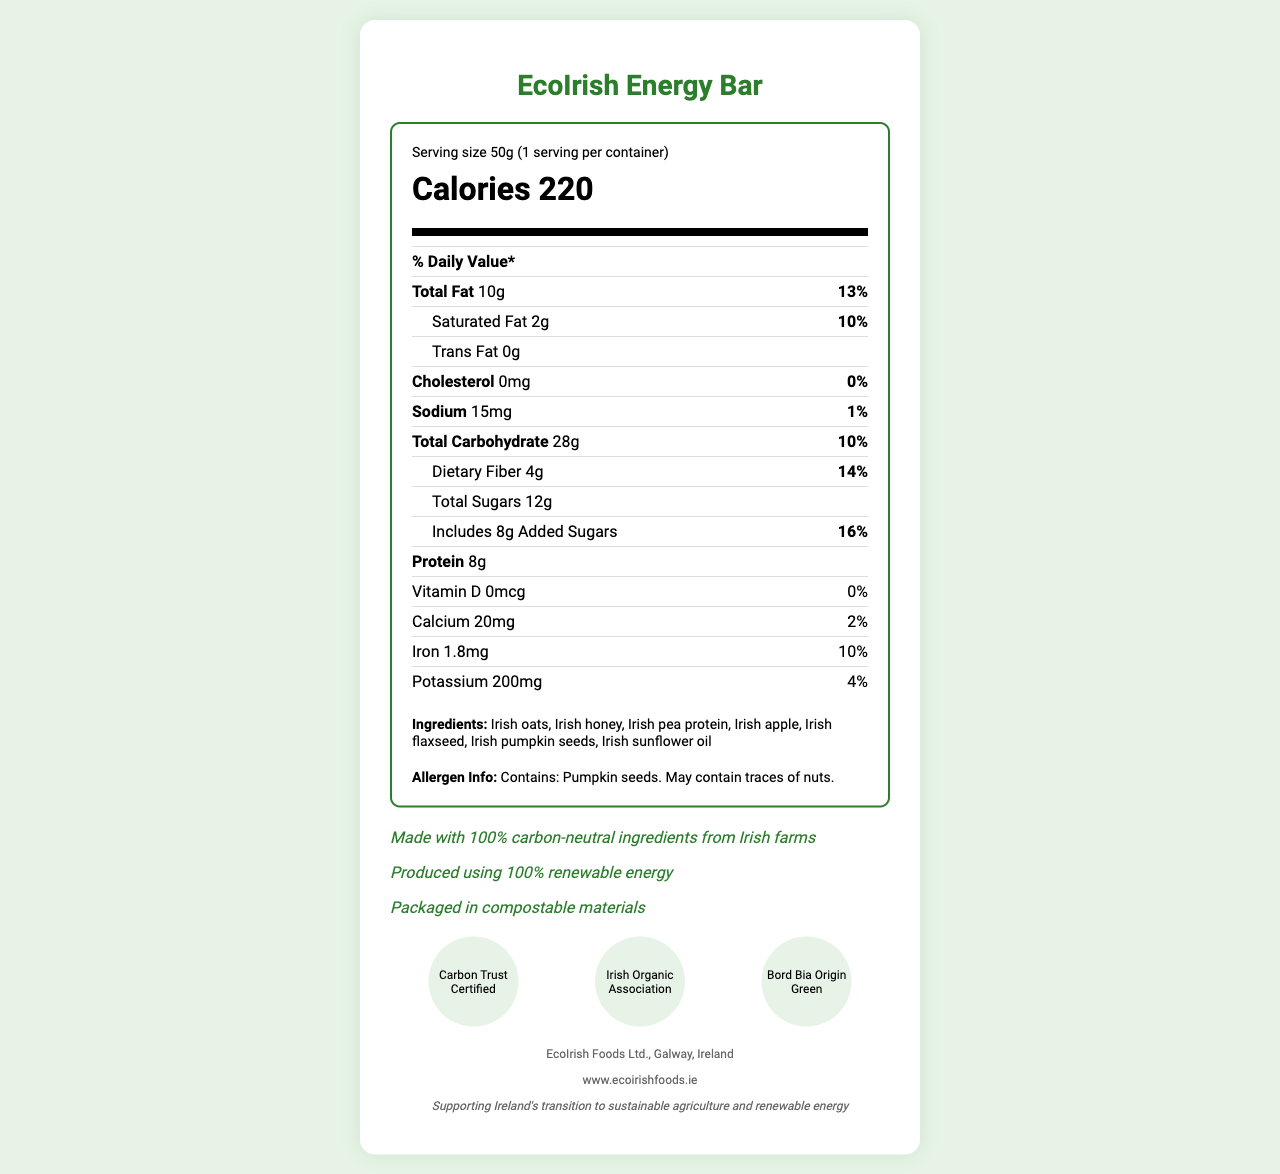what is the serving size of the EcoIrish Energy Bar? The serving size is mentioned in the "Serving size" section, which states 50g.
Answer: 50g how many calories are there per serving of the EcoIrish Energy Bar? The calories per serving are highlighted under the "Calories" section which specifies 220.
Answer: 220 calories how much saturated fat does the EcoIrish Energy Bar contain? The saturated fat content is listed under the “Total Fat” section with the amount 2g.
Answer: 2g what percentage of the daily value of dietary fiber does the EcoIrish Energy Bar provide? The daily value percentage of dietary fiber is shown as 14% in the dietary fiber section.
Answer: 14% what ingredients are used in the EcoIrish Energy Bar? The ingredient list includes these items, detailed under the "Ingredients" section.
Answer: Irish oats, Irish honey, Irish pea protein, Irish apple, Irish flaxseed, Irish pumpkin seeds, Irish sunflower oil does the EcoIrish Energy Bar contain any trans fat? The section for trans fat specifies that it contains 0g, indicating there is no trans fat.
Answer: No how much sodium is in the EcoIrish Energy Bar? The "Sodium" section mentions that the amount is 15mg.
Answer: 15mg what is the manufacturer info for the EcoIrish Energy Bar? The manufacturer information is mentioned at the end of the document, stating this.
Answer: EcoIrish Foods Ltd., Galway, Ireland which certifications does the EcoIrish Energy Bar have? (choose one) A. Carbon Trust Certified B. Fair Trade Certified C. USDA Organic D. Non-GMO Project Verified The certifications listed include "Carbon Trust Certified," but the other options are not mentioned.
Answer: A. Carbon Trust Certified which of the following is true about the EcoIrish Energy Bar’s energy production? I. Produced using 100% renewable energy II. Produced using non-renewable energy III. Produced on conventional farms A. I only B. II only C. III only D. I and II The claim "Produced using 100% renewable energy" is stated in the document, whereas the other statements are not.
Answer: A. I only is the EcoIrish Energy Bar cholesterol-free? The cholesterol content is listed as 0mg with 0% daily value, indicating it is cholesterol-free.
Answer: Yes summarize the main focus of the EcoIrish Energy Bar's Nutrition Facts Label. This summary encapsulates the overall nutritional and sustainability information presented in the document.
Answer: The EcoIrish Energy Bar Nutrition Facts Label provides detailed nutritional information per 50g serving, including 220 calories, 10g total fat, 2g saturated fat, 28g total carbohydrate, 12g total sugars, 8g added sugars, 4g dietary fiber, 8g protein, and various vitamins and minerals. It highlights sustainable and organic ingredients from carbon-neutral Irish farms and emphasizes ecological packaging and renewable energy production. The product has multiple certifications validating its eco-friendly claims. what is the amount of potassium in the EcoIrish Energy Bar? The "Potassium" section mentions the amount as 200mg.
Answer: 200mg does the EcoIrish Energy Bar contain Vitamin A? The document does not provide any information regarding Vitamin A content.
Answer: Not enough information how many servings per container does the EcoIrish Energy Bar have? It is mentioned in the "serving info" section that there is 1 serving per container.
Answer: 1 